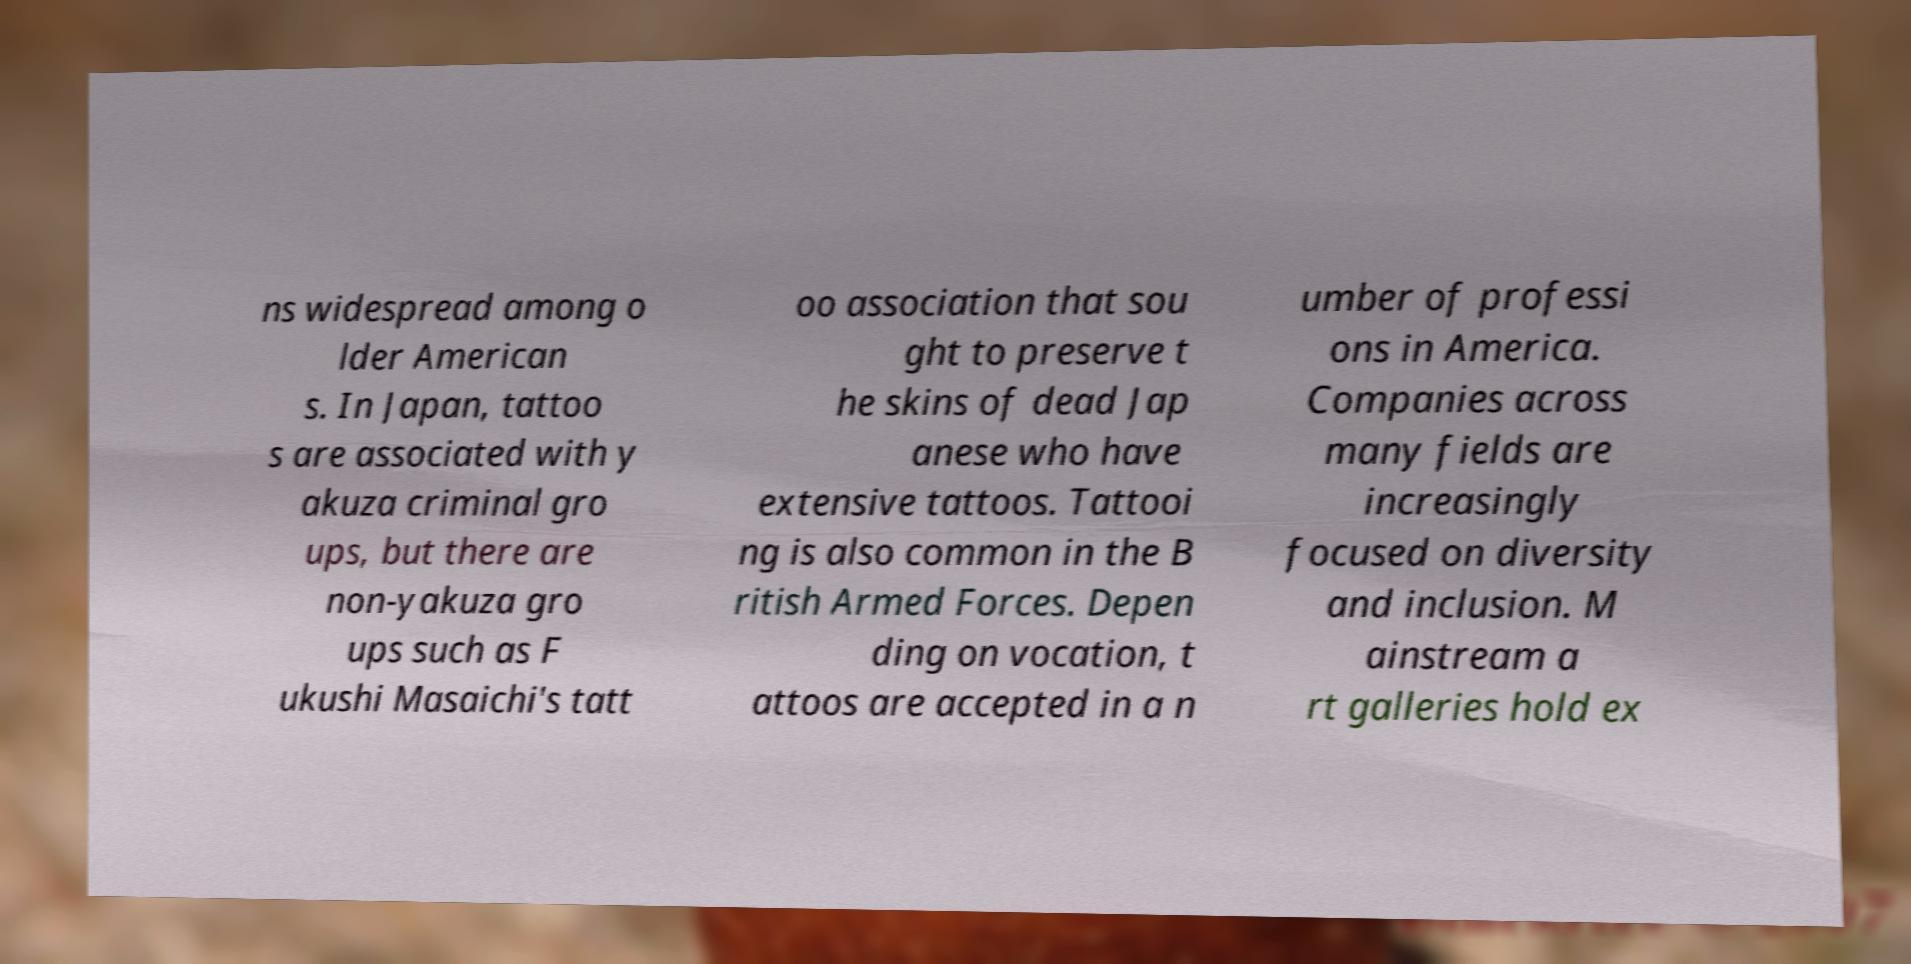I need the written content from this picture converted into text. Can you do that? ns widespread among o lder American s. In Japan, tattoo s are associated with y akuza criminal gro ups, but there are non-yakuza gro ups such as F ukushi Masaichi's tatt oo association that sou ght to preserve t he skins of dead Jap anese who have extensive tattoos. Tattooi ng is also common in the B ritish Armed Forces. Depen ding on vocation, t attoos are accepted in a n umber of professi ons in America. Companies across many fields are increasingly focused on diversity and inclusion. M ainstream a rt galleries hold ex 